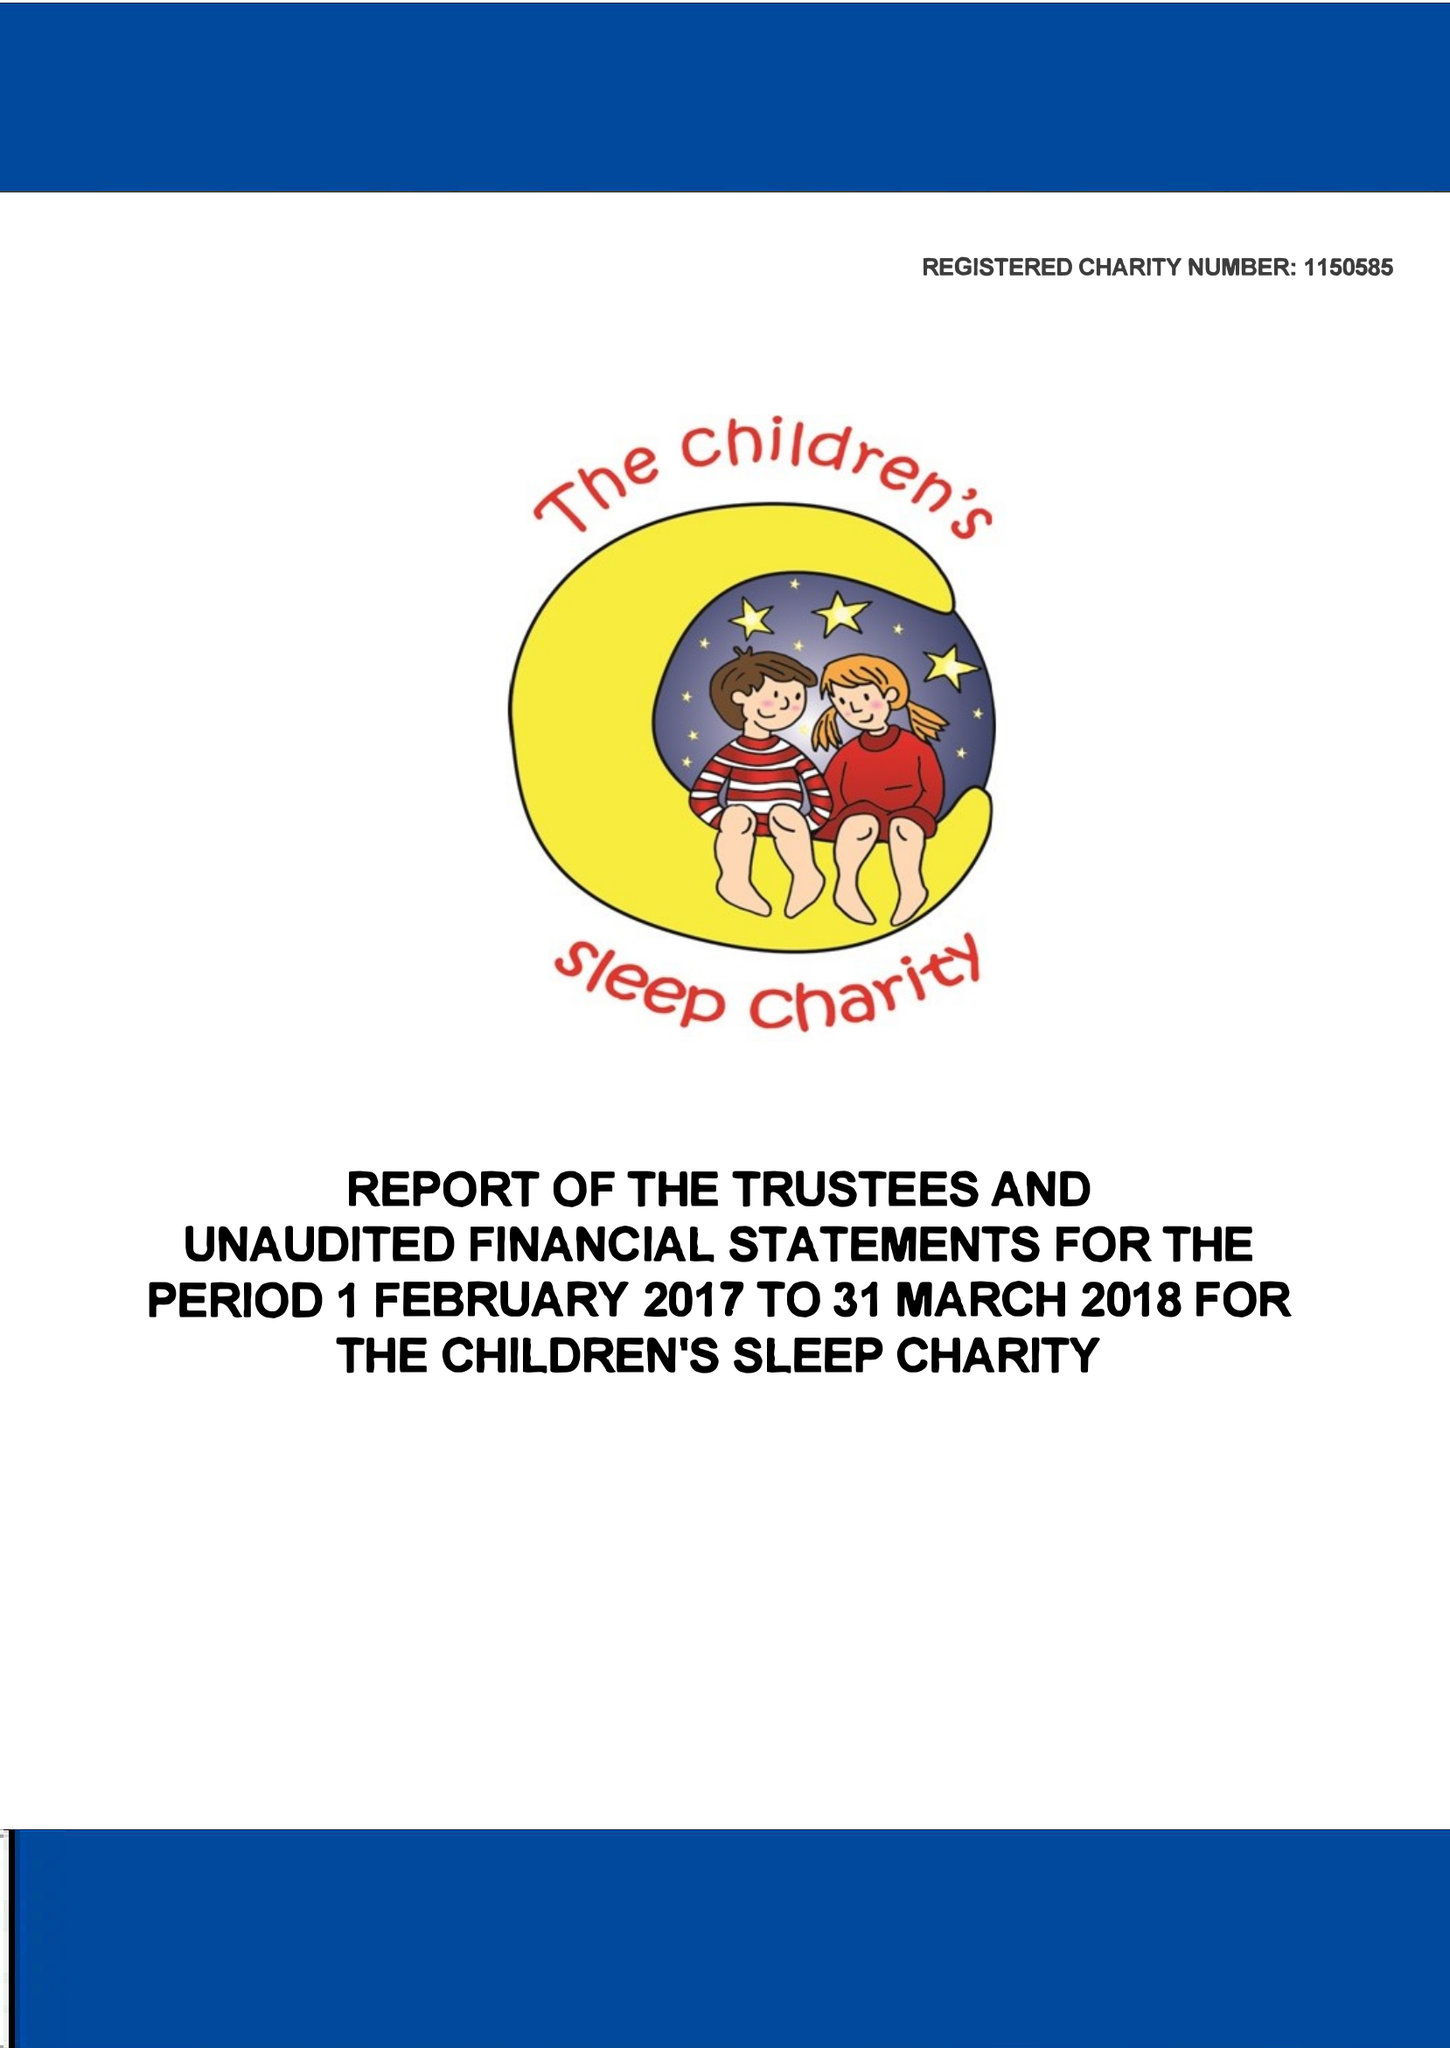What is the value for the address__post_town?
Answer the question using a single word or phrase. DONCASTER 